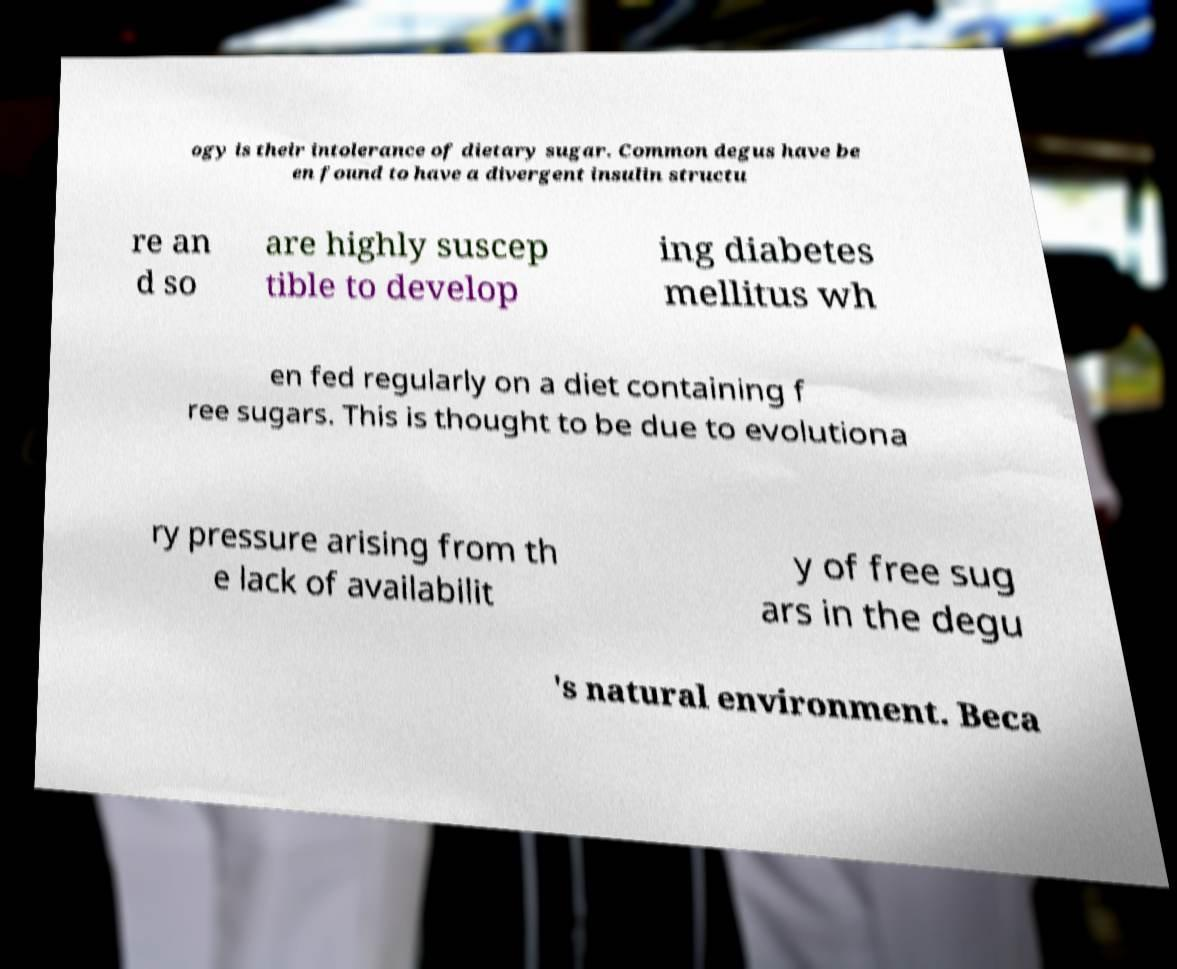Could you assist in decoding the text presented in this image and type it out clearly? ogy is their intolerance of dietary sugar. Common degus have be en found to have a divergent insulin structu re an d so are highly suscep tible to develop ing diabetes mellitus wh en fed regularly on a diet containing f ree sugars. This is thought to be due to evolutiona ry pressure arising from th e lack of availabilit y of free sug ars in the degu 's natural environment. Beca 